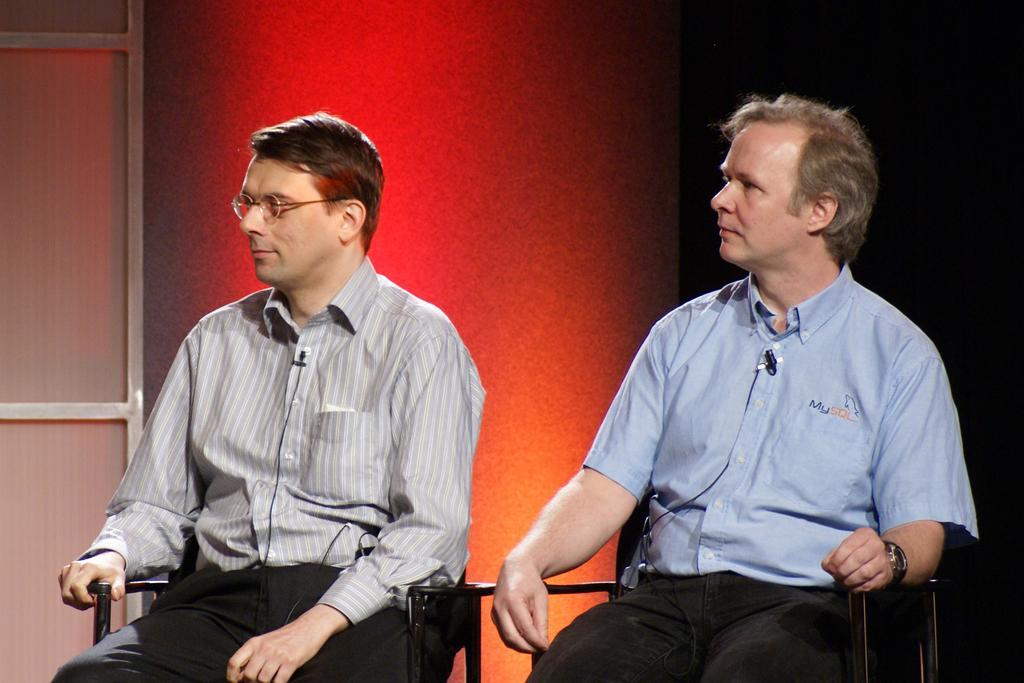How many people are in the image? There are two persons in the foreground of the image. What are the persons doing in the image? The persons are sitting on chairs. What can be seen in the background of the image? There is a wall in the background of the image. Where is the door located in the image? The door is on the left side of the image. What type of cause can be seen in the image? There is no cause present in the image; it features two persons sitting on chairs with a wall and a door in the background. 